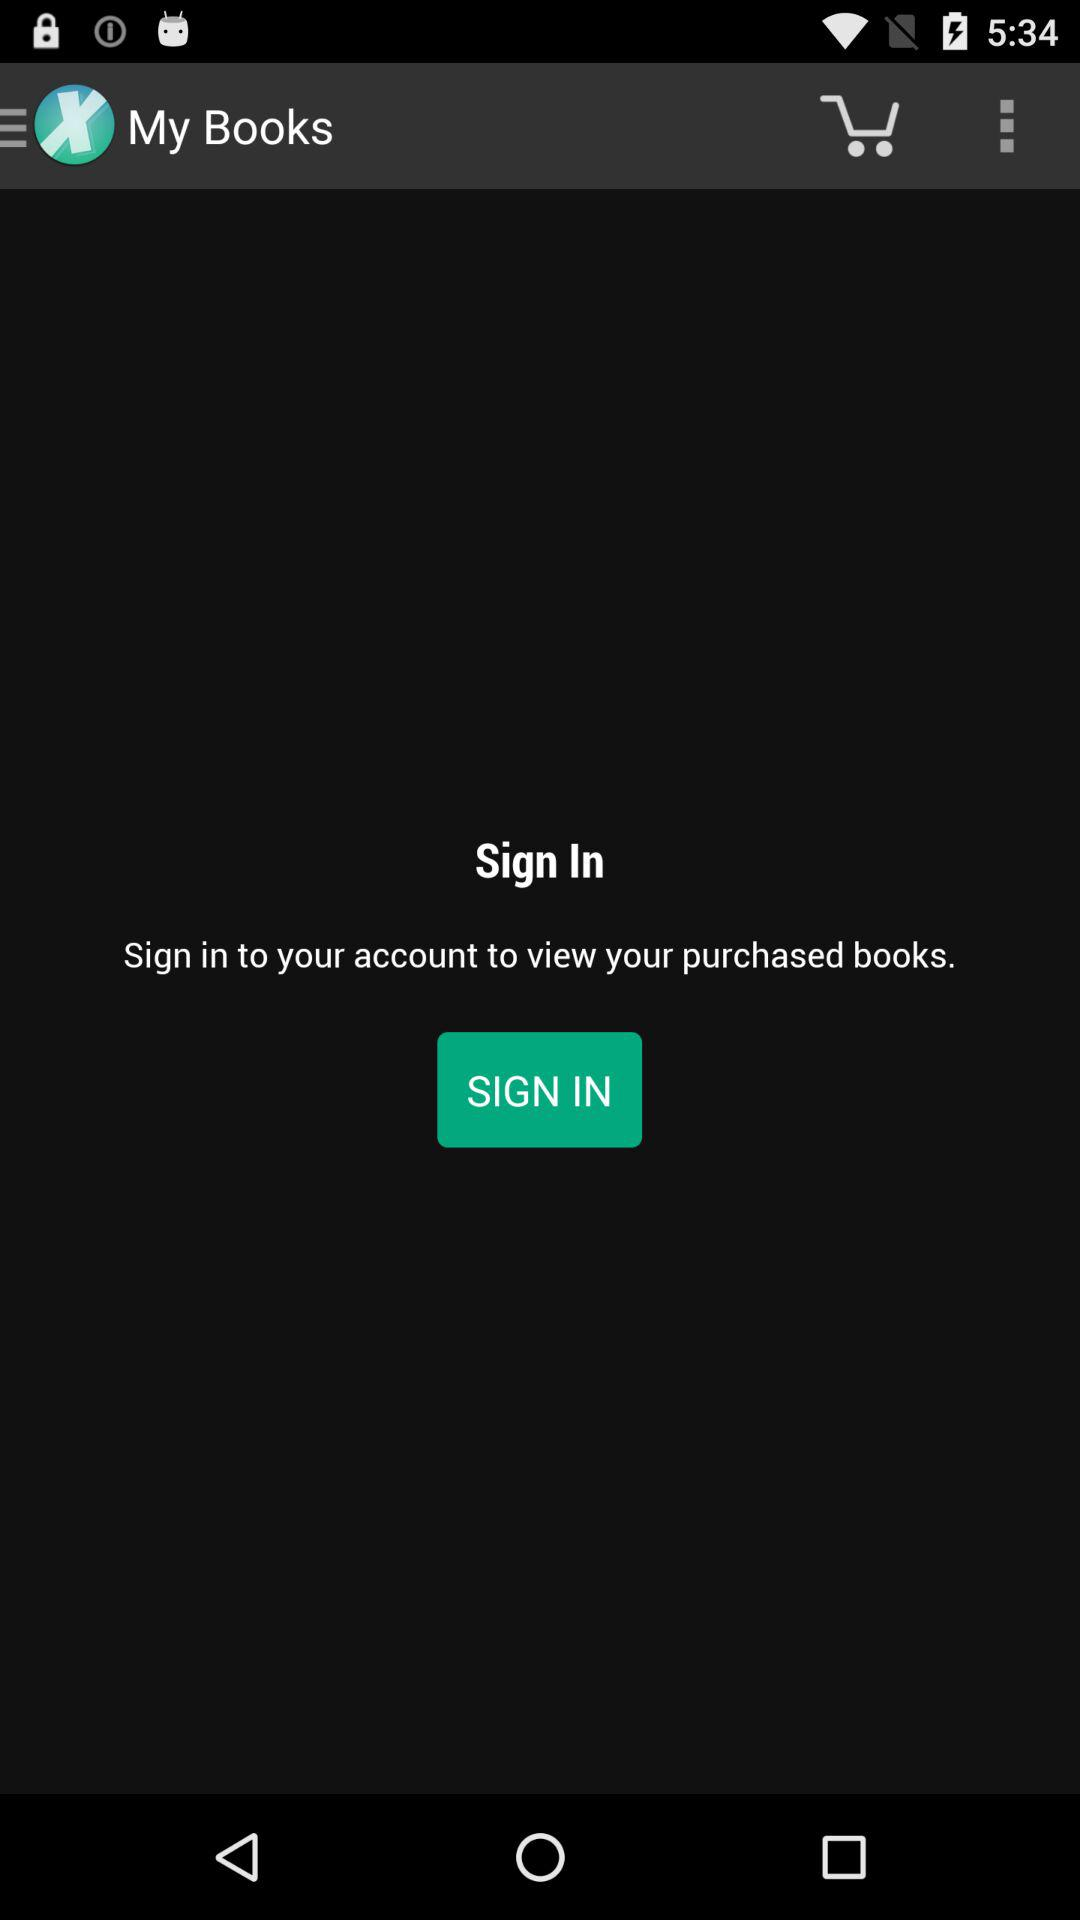What is the application name? The application name is My Books. 